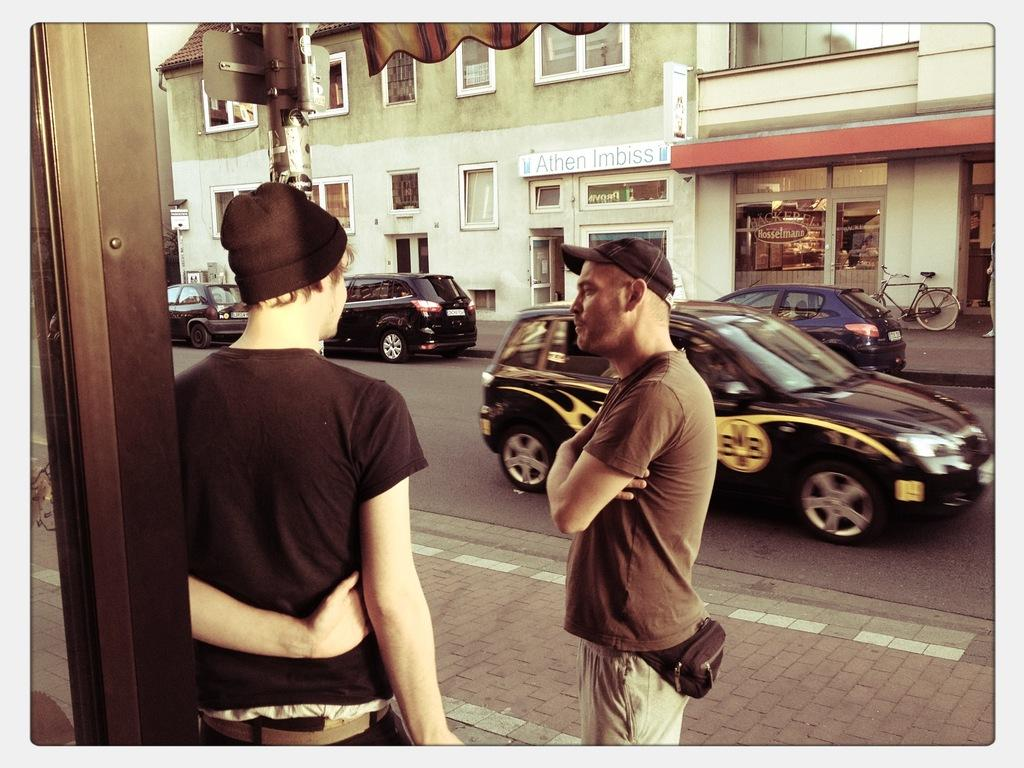What are the people in the image doing? The persons in the image are standing on the road. What can be seen in the background of the image? In the background of the image, there are cars, buildings, a pole, and a bicycle. Can you describe the setting of the image? The image shows a road with people standing on it, and there are various structures and vehicles in the background. What type of wire is being used in the war depicted in the image? There is no war or wire present in the image; it shows people standing on a road with various structures and vehicles in the background. 